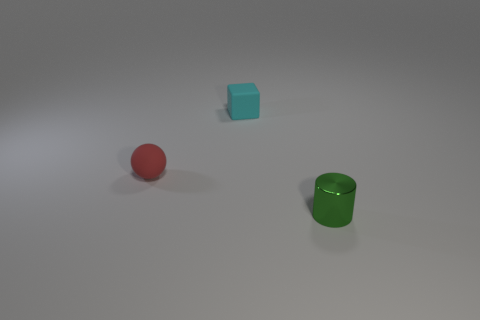Do the tiny thing behind the ball and the green cylinder have the same material?
Offer a very short reply. No. Is the red object the same shape as the shiny object?
Offer a terse response. No. How many tiny cylinders are in front of the object that is on the right side of the small cyan matte cube?
Provide a succinct answer. 0. Do the tiny object that is to the right of the tiny cyan block and the matte sphere have the same color?
Keep it short and to the point. No. Is the material of the small green thing the same as the tiny object to the left of the small cyan matte cube?
Give a very brief answer. No. There is a tiny rubber object that is in front of the cyan object; what is its shape?
Give a very brief answer. Sphere. What number of other things are there of the same material as the small green cylinder
Offer a very short reply. 0. The cylinder is what size?
Provide a succinct answer. Small. How many other objects are there of the same color as the cube?
Make the answer very short. 0. There is a small thing that is both right of the red sphere and in front of the tiny cube; what color is it?
Ensure brevity in your answer.  Green. 